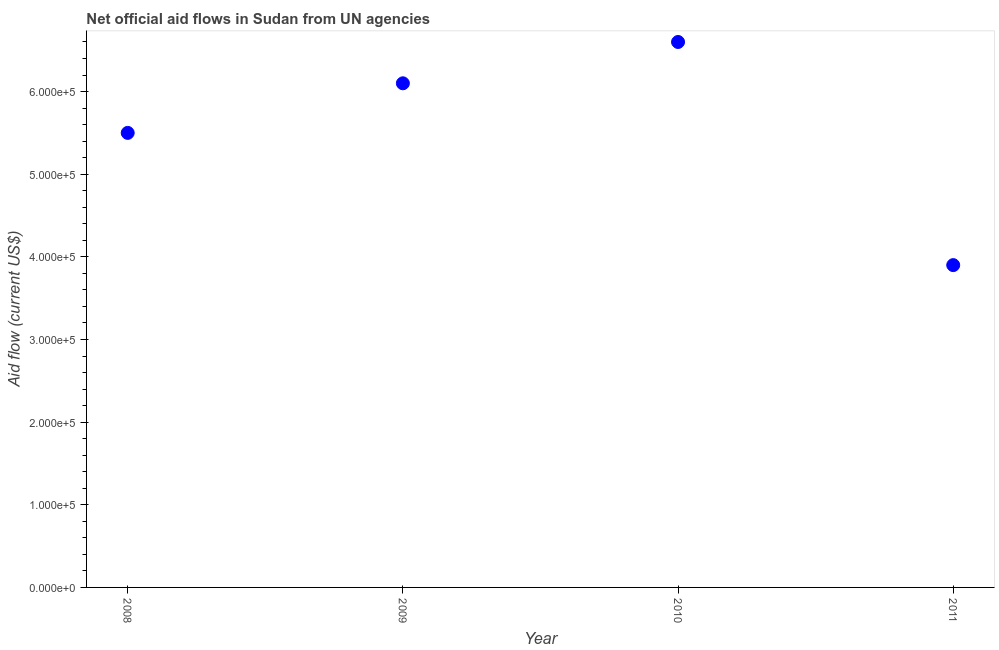What is the net official flows from un agencies in 2009?
Provide a short and direct response. 6.10e+05. Across all years, what is the maximum net official flows from un agencies?
Offer a very short reply. 6.60e+05. Across all years, what is the minimum net official flows from un agencies?
Offer a terse response. 3.90e+05. What is the sum of the net official flows from un agencies?
Make the answer very short. 2.21e+06. What is the difference between the net official flows from un agencies in 2008 and 2009?
Your response must be concise. -6.00e+04. What is the average net official flows from un agencies per year?
Offer a very short reply. 5.52e+05. What is the median net official flows from un agencies?
Give a very brief answer. 5.80e+05. In how many years, is the net official flows from un agencies greater than 80000 US$?
Provide a short and direct response. 4. What is the ratio of the net official flows from un agencies in 2008 to that in 2009?
Your answer should be very brief. 0.9. Is the sum of the net official flows from un agencies in 2010 and 2011 greater than the maximum net official flows from un agencies across all years?
Give a very brief answer. Yes. What is the difference between the highest and the lowest net official flows from un agencies?
Keep it short and to the point. 2.70e+05. In how many years, is the net official flows from un agencies greater than the average net official flows from un agencies taken over all years?
Make the answer very short. 2. Does the net official flows from un agencies monotonically increase over the years?
Provide a succinct answer. No. How many dotlines are there?
Your response must be concise. 1. Does the graph contain any zero values?
Ensure brevity in your answer.  No. Does the graph contain grids?
Your answer should be compact. No. What is the title of the graph?
Your response must be concise. Net official aid flows in Sudan from UN agencies. What is the label or title of the X-axis?
Keep it short and to the point. Year. What is the Aid flow (current US$) in 2009?
Your answer should be very brief. 6.10e+05. What is the difference between the Aid flow (current US$) in 2009 and 2010?
Make the answer very short. -5.00e+04. What is the difference between the Aid flow (current US$) in 2009 and 2011?
Keep it short and to the point. 2.20e+05. What is the ratio of the Aid flow (current US$) in 2008 to that in 2009?
Keep it short and to the point. 0.9. What is the ratio of the Aid flow (current US$) in 2008 to that in 2010?
Your response must be concise. 0.83. What is the ratio of the Aid flow (current US$) in 2008 to that in 2011?
Keep it short and to the point. 1.41. What is the ratio of the Aid flow (current US$) in 2009 to that in 2010?
Your answer should be very brief. 0.92. What is the ratio of the Aid flow (current US$) in 2009 to that in 2011?
Make the answer very short. 1.56. What is the ratio of the Aid flow (current US$) in 2010 to that in 2011?
Provide a short and direct response. 1.69. 